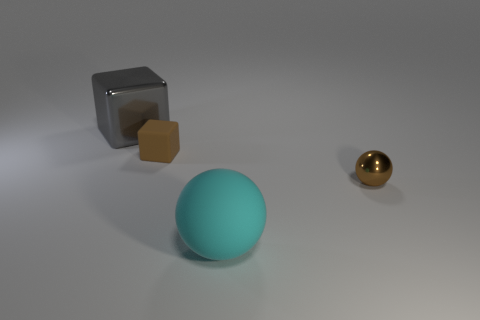Subtract 1 balls. How many balls are left? 1 Subtract all blue balls. Subtract all brown cylinders. How many balls are left? 2 Subtract all yellow balls. How many gray cubes are left? 1 Subtract all metallic balls. Subtract all rubber objects. How many objects are left? 1 Add 2 tiny things. How many tiny things are left? 4 Add 3 small blocks. How many small blocks exist? 4 Add 3 yellow metal blocks. How many objects exist? 7 Subtract 0 blue blocks. How many objects are left? 4 